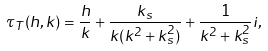<formula> <loc_0><loc_0><loc_500><loc_500>\tau _ { T } ( h , k ) = \frac { h } { k } + \frac { k _ { s } } { k ( k ^ { 2 } + k _ { s } ^ { 2 } ) } + \frac { 1 } { k ^ { 2 } + k _ { s } ^ { 2 } } i ,</formula> 